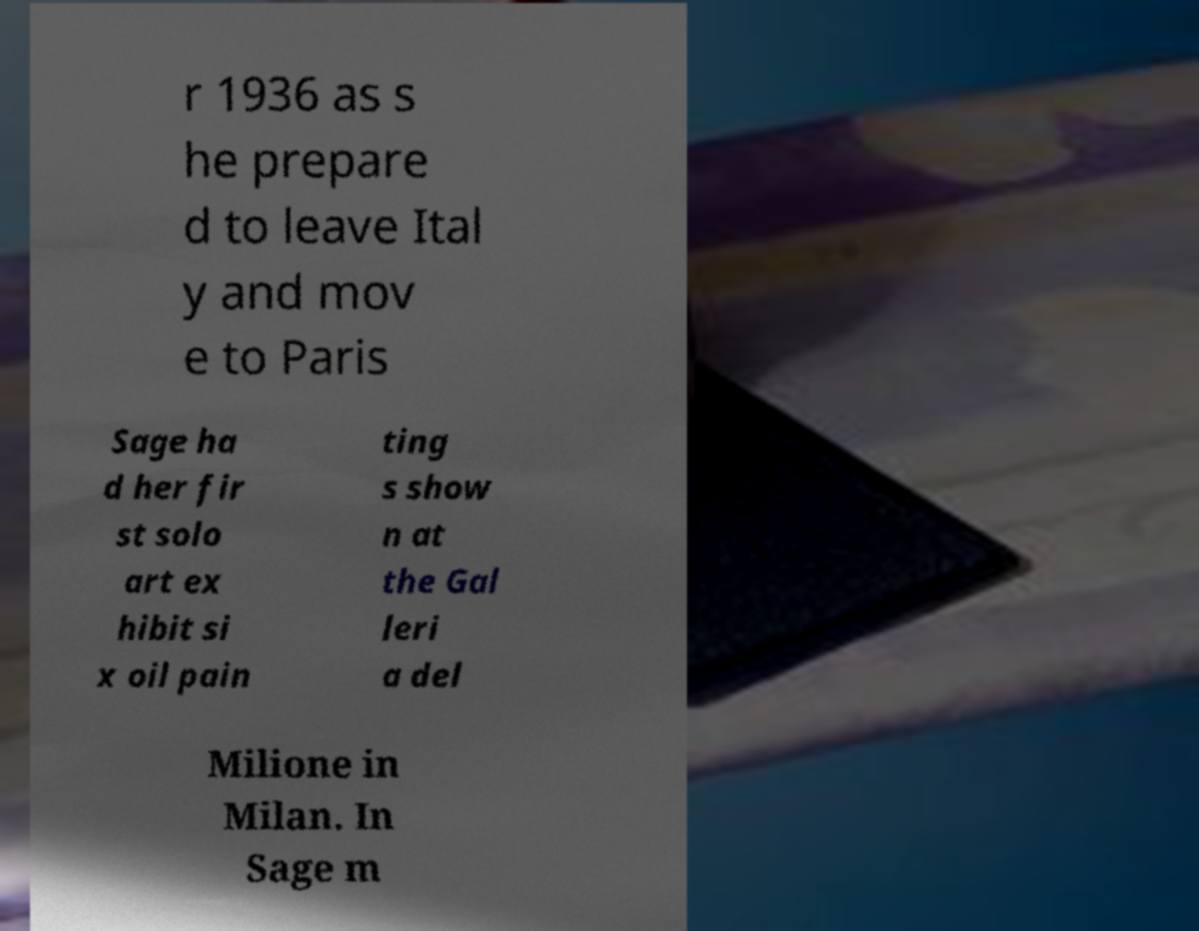Can you accurately transcribe the text from the provided image for me? r 1936 as s he prepare d to leave Ital y and mov e to Paris Sage ha d her fir st solo art ex hibit si x oil pain ting s show n at the Gal leri a del Milione in Milan. In Sage m 